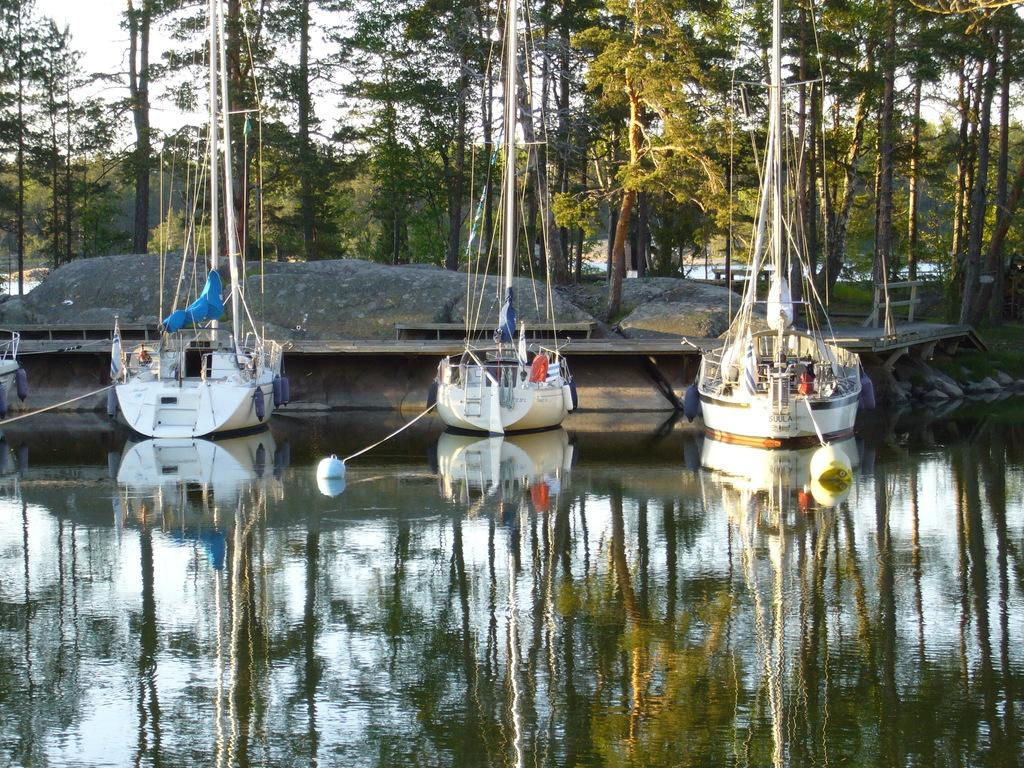What is on the water in the image? There are boats on the water in the image. What other objects can be seen in the image besides the boats? Rocks, trees, and a bench are visible in the image. What is the background of the image? The sky is visible in the background of the image. How does the wind affect the station in the image? There is no station present in the image, so the wind's effect cannot be determined. What is the desire of the trees in the image? Trees do not have desires, so this question cannot be answered. 